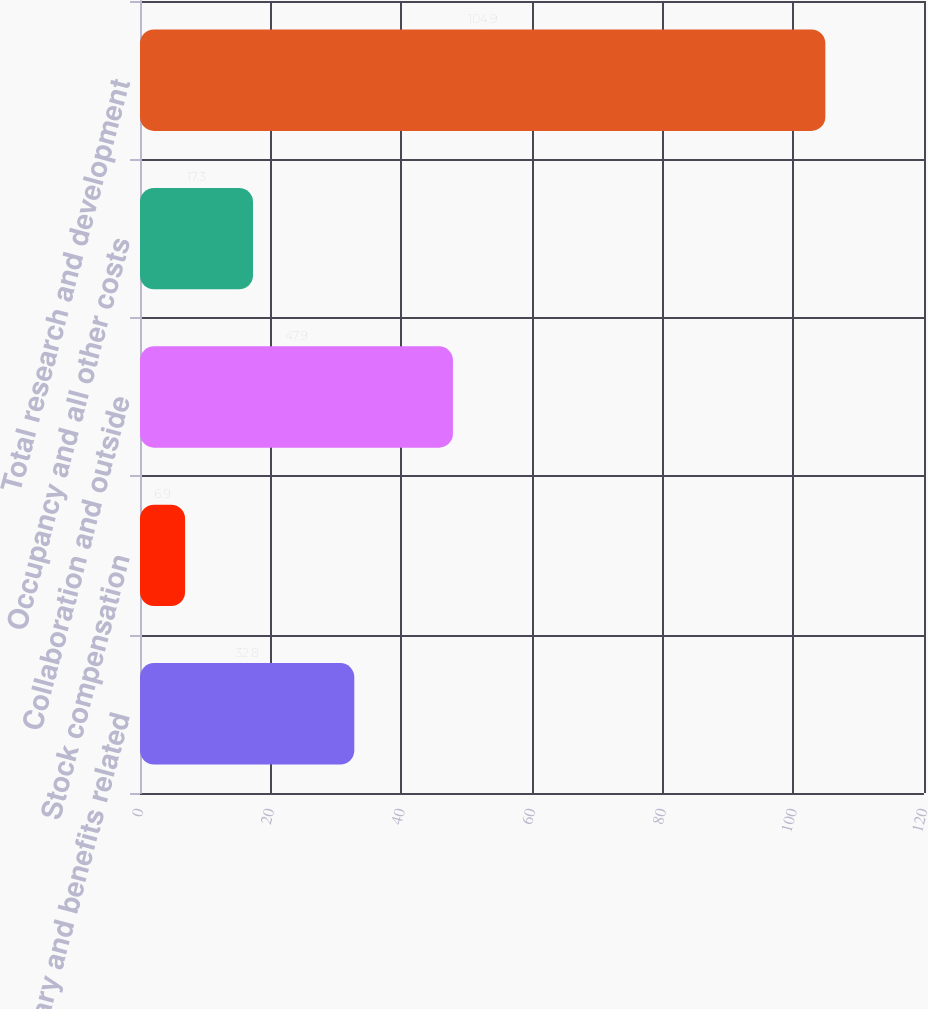Convert chart. <chart><loc_0><loc_0><loc_500><loc_500><bar_chart><fcel>Salary and benefits related<fcel>Stock compensation<fcel>Collaboration and outside<fcel>Occupancy and all other costs<fcel>Total research and development<nl><fcel>32.8<fcel>6.9<fcel>47.9<fcel>17.3<fcel>104.9<nl></chart> 